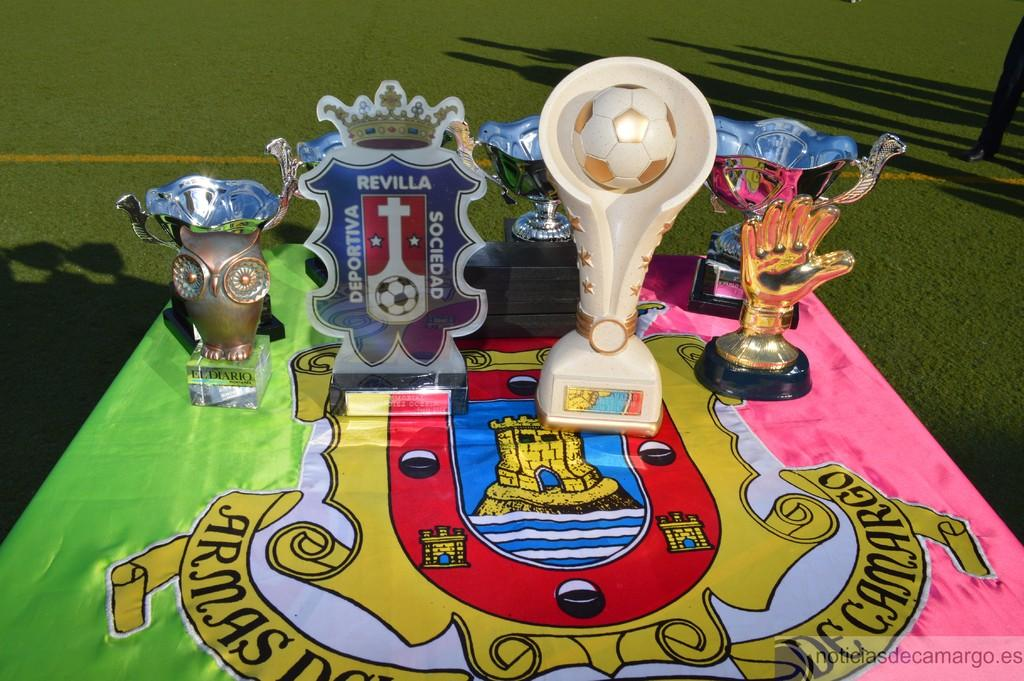<image>
Share a concise interpretation of the image provided. Four trophies placed on a table outdoors with one trophy saying "Revilla". 